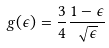<formula> <loc_0><loc_0><loc_500><loc_500>g ( \epsilon ) = \frac { 3 } { 4 } \frac { 1 - \epsilon } { \sqrt { \epsilon } }</formula> 